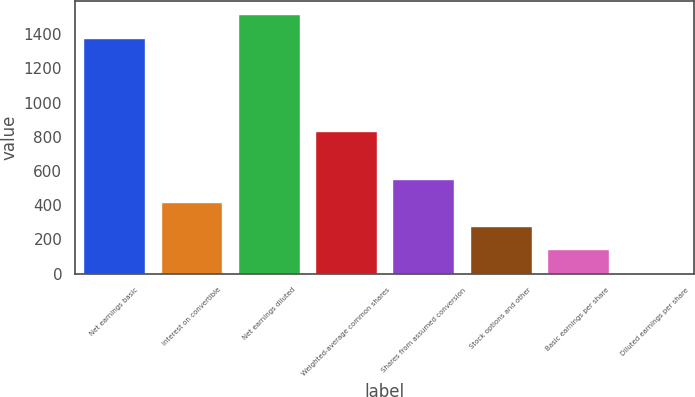<chart> <loc_0><loc_0><loc_500><loc_500><bar_chart><fcel>Net earnings basic<fcel>Interest on convertible<fcel>Net earnings diluted<fcel>Weighted-average common shares<fcel>Shares from assumed conversion<fcel>Stock options and other<fcel>Basic earnings per share<fcel>Diluted earnings per share<nl><fcel>1377<fcel>417.15<fcel>1515.12<fcel>831.51<fcel>555.27<fcel>279.03<fcel>140.91<fcel>2.79<nl></chart> 